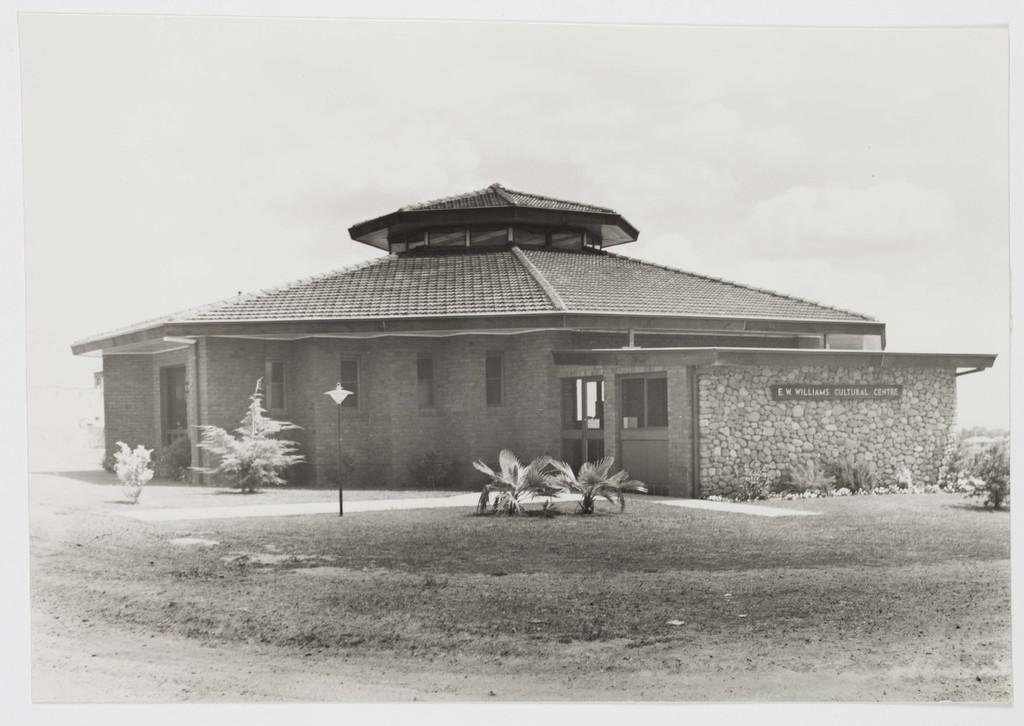What type of living organisms can be seen in the image? Plants can be seen in the image. What structure is present in the image? There is a pole in the image. What is the source of illumination in the image? There is a light in the image. What type of building is visible in the image? There is a house in the image. Is there any text or writing visible in the image? Yes, there is text or writing visible in the image. What type of thrill can be experienced by the plants in the image? There is no indication in the image that the plants are experiencing any thrill; they are simply plants. What is the answer to the question written on the house in the image? There is no question written on the house in the image, so there is no answer to provide. 